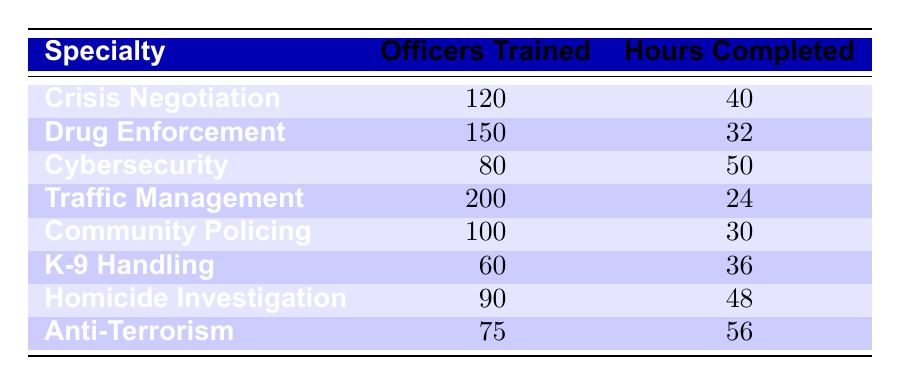What is the total number of officers trained across all specialties? The number of officers trained in each specialty is listed in the "Officers Trained" column. To find the total, we add each value: 120 + 150 + 80 + 200 + 100 + 60 + 90 + 75 = 975.
Answer: 975 Which specialty has the highest number of hours completed? We can find the highest value in the "Hours Completed" column. The values are: 40, 32, 50, 24, 30, 36, 48, 56. The highest value is 56, which corresponds to "Anti-Terrorism."
Answer: Anti-Terrorism How many more hours were completed in "Homicide Investigation" than "Drug Enforcement"? The hours completed in "Homicide Investigation" is 48, while in "Drug Enforcement" it is 32. To find the difference, we subtract: 48 - 32 = 16.
Answer: 16 True or False: More officers were trained in "Cybersecurity" than "K-9 Handling". Looking at the "Officers Trained" values, "Cybersecurity" has 80 officers trained, while "K-9 Handling" has 60. Since 80 is greater than 60, the statement is true.
Answer: True What is the average number of training hours completed across all specialties? First, we need to sum all the hours completed: 40 + 32 + 50 + 24 + 30 + 36 + 48 + 56 = 316. There are 8 specialties, so we divide the total hours by the number of specialties: 316 / 8 = 39.5.
Answer: 39.5 Which specialty has the lowest number of officers trained and how many hours were completed? The specialty with the lowest number of officers trained is "K-9 Handling," with 60 officers trained. The hours completed for this specialty are 36.
Answer: K-9 Handling, 36 What percentage of officers trained in "Traffic Management" completed training hours? There are 200 officers trained in "Traffic Management," and they completed 24 hours. To find the percentage, we calculate: (24 / 200) * 100 = 12%.
Answer: 12% How many officers were trained in "Crisis Negotiation" and "Community Policing" combined? The number of officers trained in "Crisis Negotiation" is 120, and in "Community Policing" it is 100. We add these: 120 + 100 = 220.
Answer: 220 